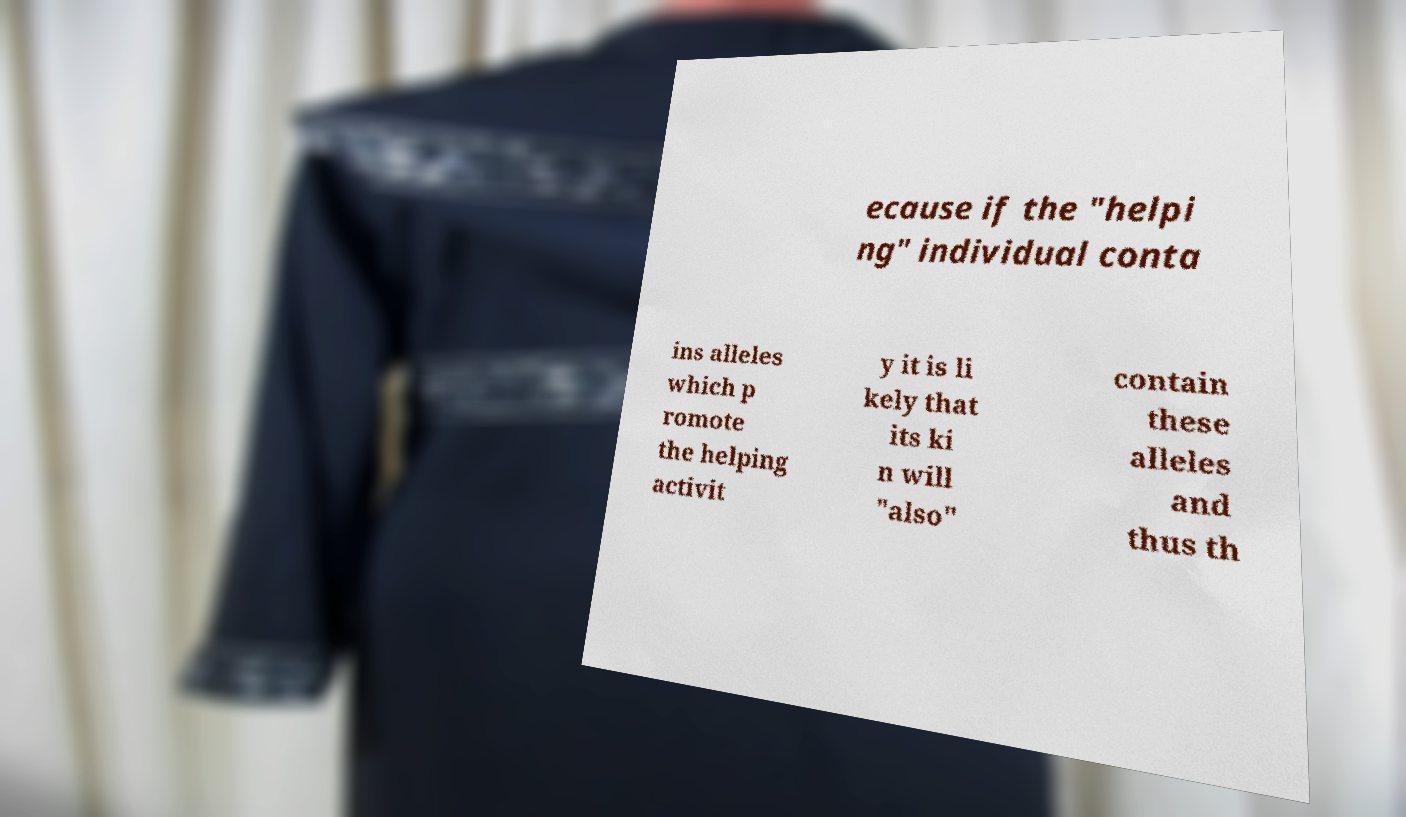Could you assist in decoding the text presented in this image and type it out clearly? ecause if the "helpi ng" individual conta ins alleles which p romote the helping activit y it is li kely that its ki n will "also" contain these alleles and thus th 